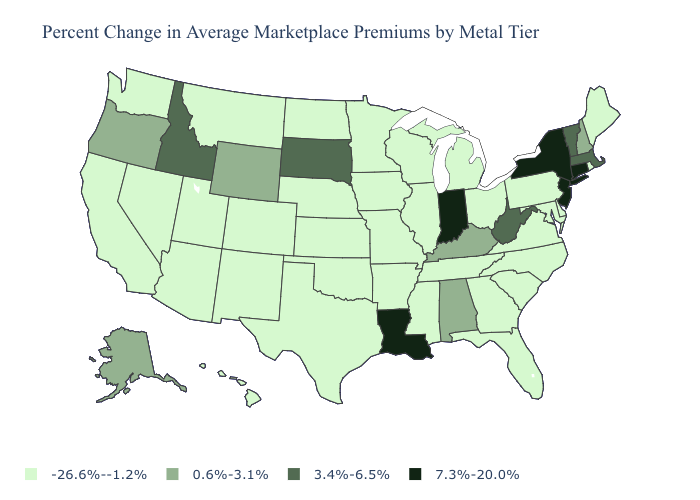Name the states that have a value in the range 7.3%-20.0%?
Write a very short answer. Connecticut, Indiana, Louisiana, New Jersey, New York. Name the states that have a value in the range 7.3%-20.0%?
Give a very brief answer. Connecticut, Indiana, Louisiana, New Jersey, New York. What is the value of North Carolina?
Answer briefly. -26.6%--1.2%. What is the highest value in the USA?
Quick response, please. 7.3%-20.0%. Name the states that have a value in the range 7.3%-20.0%?
Short answer required. Connecticut, Indiana, Louisiana, New Jersey, New York. Name the states that have a value in the range 3.4%-6.5%?
Short answer required. Idaho, Massachusetts, South Dakota, Vermont, West Virginia. What is the value of North Dakota?
Keep it brief. -26.6%--1.2%. Does the first symbol in the legend represent the smallest category?
Quick response, please. Yes. What is the lowest value in the USA?
Concise answer only. -26.6%--1.2%. What is the highest value in the USA?
Write a very short answer. 7.3%-20.0%. Name the states that have a value in the range 7.3%-20.0%?
Give a very brief answer. Connecticut, Indiana, Louisiana, New Jersey, New York. What is the value of Delaware?
Answer briefly. -26.6%--1.2%. What is the value of Minnesota?
Concise answer only. -26.6%--1.2%. Is the legend a continuous bar?
Give a very brief answer. No. Among the states that border Oklahoma , which have the lowest value?
Keep it brief. Arkansas, Colorado, Kansas, Missouri, New Mexico, Texas. 